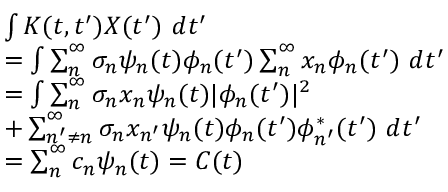<formula> <loc_0><loc_0><loc_500><loc_500>\begin{array} { r l } & { \int K ( t , t ^ { \prime } ) X ( t ^ { \prime } ) d t ^ { \prime } } \\ & { = \int \sum _ { n } ^ { \infty } \sigma _ { n } \psi _ { n } ( t ) \phi _ { n } ( t ^ { \prime } ) \sum _ { n } ^ { \infty } x _ { n } \phi _ { n } ( t ^ { \prime } ) d t ^ { \prime } } \\ & { = \int \sum _ { n } ^ { \infty } \sigma _ { n } x _ { n } \psi _ { n } ( t ) | \phi _ { n } ( t ^ { \prime } ) | ^ { 2 } } \\ & { + \sum _ { n ^ { \prime } \neq n } ^ { \infty } \sigma _ { n } x _ { n ^ { \prime } } \psi _ { n } ( t ) \phi _ { n } ( t ^ { \prime } ) \phi _ { n ^ { \prime } } ^ { * } ( t ^ { \prime } ) d t ^ { \prime } } \\ & { = \sum _ { n } ^ { \infty } c _ { n } \psi _ { n } ( t ) = C ( t ) } \end{array}</formula> 